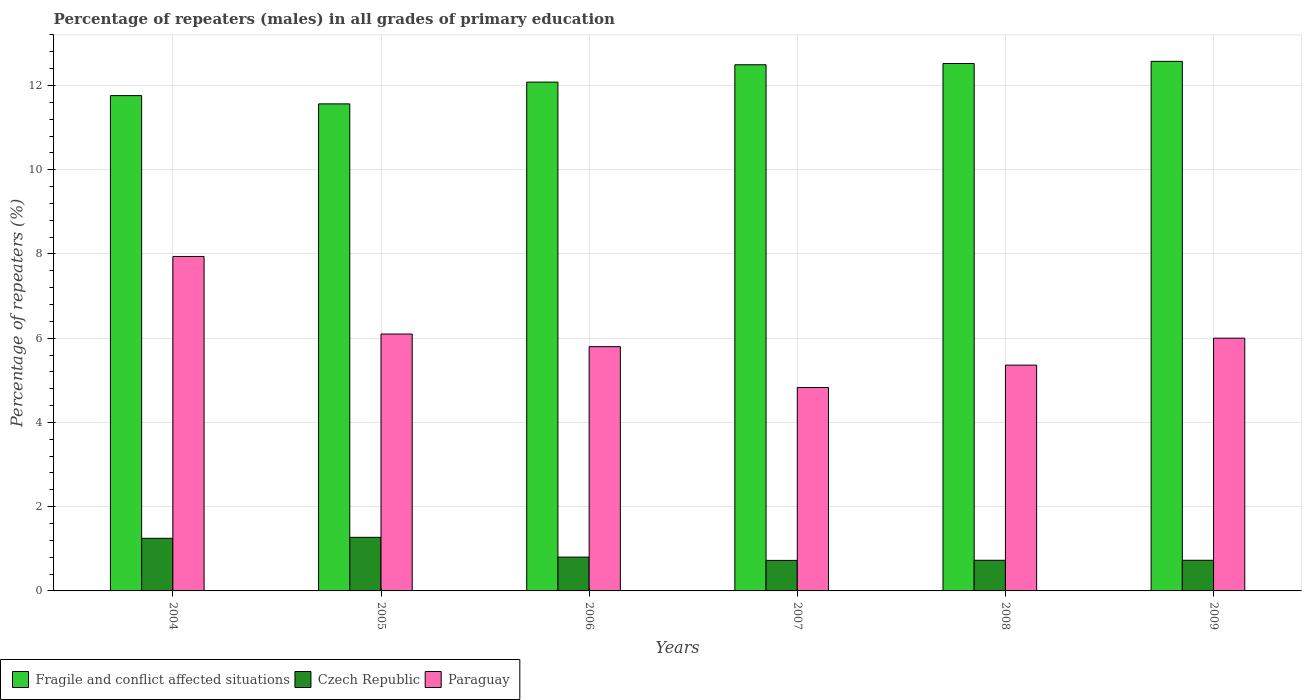Are the number of bars per tick equal to the number of legend labels?
Ensure brevity in your answer.  Yes. Are the number of bars on each tick of the X-axis equal?
Offer a terse response. Yes. What is the label of the 3rd group of bars from the left?
Your answer should be very brief. 2006. What is the percentage of repeaters (males) in Paraguay in 2005?
Ensure brevity in your answer.  6.1. Across all years, what is the maximum percentage of repeaters (males) in Paraguay?
Give a very brief answer. 7.94. Across all years, what is the minimum percentage of repeaters (males) in Paraguay?
Offer a terse response. 4.83. What is the total percentage of repeaters (males) in Paraguay in the graph?
Your answer should be very brief. 36.03. What is the difference between the percentage of repeaters (males) in Czech Republic in 2006 and that in 2009?
Your response must be concise. 0.07. What is the difference between the percentage of repeaters (males) in Fragile and conflict affected situations in 2008 and the percentage of repeaters (males) in Czech Republic in 2009?
Offer a very short reply. 11.8. What is the average percentage of repeaters (males) in Paraguay per year?
Offer a very short reply. 6.01. In the year 2004, what is the difference between the percentage of repeaters (males) in Fragile and conflict affected situations and percentage of repeaters (males) in Paraguay?
Provide a short and direct response. 3.82. In how many years, is the percentage of repeaters (males) in Czech Republic greater than 3.6 %?
Your response must be concise. 0. What is the ratio of the percentage of repeaters (males) in Fragile and conflict affected situations in 2005 to that in 2009?
Give a very brief answer. 0.92. What is the difference between the highest and the second highest percentage of repeaters (males) in Czech Republic?
Offer a very short reply. 0.02. What is the difference between the highest and the lowest percentage of repeaters (males) in Czech Republic?
Offer a very short reply. 0.55. Is the sum of the percentage of repeaters (males) in Czech Republic in 2005 and 2007 greater than the maximum percentage of repeaters (males) in Fragile and conflict affected situations across all years?
Make the answer very short. No. What does the 1st bar from the left in 2004 represents?
Your answer should be compact. Fragile and conflict affected situations. What does the 2nd bar from the right in 2005 represents?
Provide a short and direct response. Czech Republic. Is it the case that in every year, the sum of the percentage of repeaters (males) in Fragile and conflict affected situations and percentage of repeaters (males) in Paraguay is greater than the percentage of repeaters (males) in Czech Republic?
Your answer should be compact. Yes. How many bars are there?
Your response must be concise. 18. Are all the bars in the graph horizontal?
Your answer should be compact. No. How many years are there in the graph?
Your response must be concise. 6. What is the difference between two consecutive major ticks on the Y-axis?
Your answer should be very brief. 2. Are the values on the major ticks of Y-axis written in scientific E-notation?
Your answer should be very brief. No. Where does the legend appear in the graph?
Your answer should be very brief. Bottom left. What is the title of the graph?
Make the answer very short. Percentage of repeaters (males) in all grades of primary education. What is the label or title of the X-axis?
Provide a succinct answer. Years. What is the label or title of the Y-axis?
Give a very brief answer. Percentage of repeaters (%). What is the Percentage of repeaters (%) in Fragile and conflict affected situations in 2004?
Provide a short and direct response. 11.76. What is the Percentage of repeaters (%) in Czech Republic in 2004?
Provide a short and direct response. 1.25. What is the Percentage of repeaters (%) of Paraguay in 2004?
Your answer should be very brief. 7.94. What is the Percentage of repeaters (%) of Fragile and conflict affected situations in 2005?
Ensure brevity in your answer.  11.56. What is the Percentage of repeaters (%) of Czech Republic in 2005?
Offer a very short reply. 1.27. What is the Percentage of repeaters (%) of Paraguay in 2005?
Provide a short and direct response. 6.1. What is the Percentage of repeaters (%) of Fragile and conflict affected situations in 2006?
Offer a terse response. 12.08. What is the Percentage of repeaters (%) of Czech Republic in 2006?
Offer a terse response. 0.8. What is the Percentage of repeaters (%) in Paraguay in 2006?
Your response must be concise. 5.8. What is the Percentage of repeaters (%) in Fragile and conflict affected situations in 2007?
Offer a very short reply. 12.49. What is the Percentage of repeaters (%) of Czech Republic in 2007?
Keep it short and to the point. 0.72. What is the Percentage of repeaters (%) of Paraguay in 2007?
Offer a terse response. 4.83. What is the Percentage of repeaters (%) of Fragile and conflict affected situations in 2008?
Keep it short and to the point. 12.52. What is the Percentage of repeaters (%) in Czech Republic in 2008?
Give a very brief answer. 0.73. What is the Percentage of repeaters (%) in Paraguay in 2008?
Make the answer very short. 5.36. What is the Percentage of repeaters (%) of Fragile and conflict affected situations in 2009?
Make the answer very short. 12.57. What is the Percentage of repeaters (%) of Czech Republic in 2009?
Your answer should be compact. 0.73. What is the Percentage of repeaters (%) of Paraguay in 2009?
Your answer should be compact. 6. Across all years, what is the maximum Percentage of repeaters (%) in Fragile and conflict affected situations?
Ensure brevity in your answer.  12.57. Across all years, what is the maximum Percentage of repeaters (%) in Czech Republic?
Offer a terse response. 1.27. Across all years, what is the maximum Percentage of repeaters (%) in Paraguay?
Your answer should be compact. 7.94. Across all years, what is the minimum Percentage of repeaters (%) in Fragile and conflict affected situations?
Provide a short and direct response. 11.56. Across all years, what is the minimum Percentage of repeaters (%) in Czech Republic?
Give a very brief answer. 0.72. Across all years, what is the minimum Percentage of repeaters (%) of Paraguay?
Provide a short and direct response. 4.83. What is the total Percentage of repeaters (%) in Fragile and conflict affected situations in the graph?
Ensure brevity in your answer.  72.99. What is the total Percentage of repeaters (%) of Czech Republic in the graph?
Offer a very short reply. 5.5. What is the total Percentage of repeaters (%) of Paraguay in the graph?
Your answer should be compact. 36.03. What is the difference between the Percentage of repeaters (%) in Fragile and conflict affected situations in 2004 and that in 2005?
Offer a very short reply. 0.2. What is the difference between the Percentage of repeaters (%) in Czech Republic in 2004 and that in 2005?
Your response must be concise. -0.02. What is the difference between the Percentage of repeaters (%) of Paraguay in 2004 and that in 2005?
Ensure brevity in your answer.  1.84. What is the difference between the Percentage of repeaters (%) of Fragile and conflict affected situations in 2004 and that in 2006?
Your answer should be very brief. -0.32. What is the difference between the Percentage of repeaters (%) in Czech Republic in 2004 and that in 2006?
Provide a succinct answer. 0.45. What is the difference between the Percentage of repeaters (%) of Paraguay in 2004 and that in 2006?
Give a very brief answer. 2.14. What is the difference between the Percentage of repeaters (%) of Fragile and conflict affected situations in 2004 and that in 2007?
Your answer should be compact. -0.73. What is the difference between the Percentage of repeaters (%) in Czech Republic in 2004 and that in 2007?
Offer a very short reply. 0.52. What is the difference between the Percentage of repeaters (%) in Paraguay in 2004 and that in 2007?
Provide a short and direct response. 3.11. What is the difference between the Percentage of repeaters (%) of Fragile and conflict affected situations in 2004 and that in 2008?
Your answer should be compact. -0.76. What is the difference between the Percentage of repeaters (%) in Czech Republic in 2004 and that in 2008?
Provide a succinct answer. 0.52. What is the difference between the Percentage of repeaters (%) of Paraguay in 2004 and that in 2008?
Ensure brevity in your answer.  2.58. What is the difference between the Percentage of repeaters (%) of Fragile and conflict affected situations in 2004 and that in 2009?
Your response must be concise. -0.81. What is the difference between the Percentage of repeaters (%) in Czech Republic in 2004 and that in 2009?
Ensure brevity in your answer.  0.52. What is the difference between the Percentage of repeaters (%) of Paraguay in 2004 and that in 2009?
Ensure brevity in your answer.  1.94. What is the difference between the Percentage of repeaters (%) of Fragile and conflict affected situations in 2005 and that in 2006?
Your answer should be compact. -0.52. What is the difference between the Percentage of repeaters (%) of Czech Republic in 2005 and that in 2006?
Offer a terse response. 0.47. What is the difference between the Percentage of repeaters (%) of Paraguay in 2005 and that in 2006?
Offer a very short reply. 0.3. What is the difference between the Percentage of repeaters (%) of Fragile and conflict affected situations in 2005 and that in 2007?
Your answer should be compact. -0.93. What is the difference between the Percentage of repeaters (%) of Czech Republic in 2005 and that in 2007?
Keep it short and to the point. 0.55. What is the difference between the Percentage of repeaters (%) in Paraguay in 2005 and that in 2007?
Your answer should be very brief. 1.27. What is the difference between the Percentage of repeaters (%) of Fragile and conflict affected situations in 2005 and that in 2008?
Your answer should be very brief. -0.96. What is the difference between the Percentage of repeaters (%) of Czech Republic in 2005 and that in 2008?
Your answer should be very brief. 0.54. What is the difference between the Percentage of repeaters (%) in Paraguay in 2005 and that in 2008?
Keep it short and to the point. 0.74. What is the difference between the Percentage of repeaters (%) in Fragile and conflict affected situations in 2005 and that in 2009?
Your answer should be compact. -1.01. What is the difference between the Percentage of repeaters (%) of Czech Republic in 2005 and that in 2009?
Offer a very short reply. 0.54. What is the difference between the Percentage of repeaters (%) of Paraguay in 2005 and that in 2009?
Give a very brief answer. 0.1. What is the difference between the Percentage of repeaters (%) of Fragile and conflict affected situations in 2006 and that in 2007?
Keep it short and to the point. -0.41. What is the difference between the Percentage of repeaters (%) of Czech Republic in 2006 and that in 2007?
Ensure brevity in your answer.  0.08. What is the difference between the Percentage of repeaters (%) of Paraguay in 2006 and that in 2007?
Your answer should be compact. 0.97. What is the difference between the Percentage of repeaters (%) of Fragile and conflict affected situations in 2006 and that in 2008?
Your response must be concise. -0.44. What is the difference between the Percentage of repeaters (%) in Czech Republic in 2006 and that in 2008?
Keep it short and to the point. 0.08. What is the difference between the Percentage of repeaters (%) of Paraguay in 2006 and that in 2008?
Provide a succinct answer. 0.44. What is the difference between the Percentage of repeaters (%) of Fragile and conflict affected situations in 2006 and that in 2009?
Ensure brevity in your answer.  -0.49. What is the difference between the Percentage of repeaters (%) in Czech Republic in 2006 and that in 2009?
Keep it short and to the point. 0.07. What is the difference between the Percentage of repeaters (%) of Paraguay in 2006 and that in 2009?
Keep it short and to the point. -0.2. What is the difference between the Percentage of repeaters (%) of Fragile and conflict affected situations in 2007 and that in 2008?
Provide a short and direct response. -0.03. What is the difference between the Percentage of repeaters (%) of Czech Republic in 2007 and that in 2008?
Make the answer very short. -0. What is the difference between the Percentage of repeaters (%) in Paraguay in 2007 and that in 2008?
Ensure brevity in your answer.  -0.53. What is the difference between the Percentage of repeaters (%) in Fragile and conflict affected situations in 2007 and that in 2009?
Keep it short and to the point. -0.08. What is the difference between the Percentage of repeaters (%) in Czech Republic in 2007 and that in 2009?
Make the answer very short. -0. What is the difference between the Percentage of repeaters (%) in Paraguay in 2007 and that in 2009?
Keep it short and to the point. -1.17. What is the difference between the Percentage of repeaters (%) of Fragile and conflict affected situations in 2008 and that in 2009?
Your answer should be very brief. -0.05. What is the difference between the Percentage of repeaters (%) in Czech Republic in 2008 and that in 2009?
Your answer should be very brief. -0. What is the difference between the Percentage of repeaters (%) in Paraguay in 2008 and that in 2009?
Provide a short and direct response. -0.64. What is the difference between the Percentage of repeaters (%) of Fragile and conflict affected situations in 2004 and the Percentage of repeaters (%) of Czech Republic in 2005?
Your response must be concise. 10.49. What is the difference between the Percentage of repeaters (%) of Fragile and conflict affected situations in 2004 and the Percentage of repeaters (%) of Paraguay in 2005?
Make the answer very short. 5.66. What is the difference between the Percentage of repeaters (%) of Czech Republic in 2004 and the Percentage of repeaters (%) of Paraguay in 2005?
Your answer should be very brief. -4.85. What is the difference between the Percentage of repeaters (%) in Fragile and conflict affected situations in 2004 and the Percentage of repeaters (%) in Czech Republic in 2006?
Offer a terse response. 10.96. What is the difference between the Percentage of repeaters (%) in Fragile and conflict affected situations in 2004 and the Percentage of repeaters (%) in Paraguay in 2006?
Provide a short and direct response. 5.96. What is the difference between the Percentage of repeaters (%) in Czech Republic in 2004 and the Percentage of repeaters (%) in Paraguay in 2006?
Provide a short and direct response. -4.55. What is the difference between the Percentage of repeaters (%) of Fragile and conflict affected situations in 2004 and the Percentage of repeaters (%) of Czech Republic in 2007?
Offer a very short reply. 11.04. What is the difference between the Percentage of repeaters (%) in Fragile and conflict affected situations in 2004 and the Percentage of repeaters (%) in Paraguay in 2007?
Keep it short and to the point. 6.93. What is the difference between the Percentage of repeaters (%) of Czech Republic in 2004 and the Percentage of repeaters (%) of Paraguay in 2007?
Offer a very short reply. -3.58. What is the difference between the Percentage of repeaters (%) in Fragile and conflict affected situations in 2004 and the Percentage of repeaters (%) in Czech Republic in 2008?
Your answer should be compact. 11.03. What is the difference between the Percentage of repeaters (%) in Fragile and conflict affected situations in 2004 and the Percentage of repeaters (%) in Paraguay in 2008?
Your answer should be very brief. 6.4. What is the difference between the Percentage of repeaters (%) in Czech Republic in 2004 and the Percentage of repeaters (%) in Paraguay in 2008?
Ensure brevity in your answer.  -4.11. What is the difference between the Percentage of repeaters (%) in Fragile and conflict affected situations in 2004 and the Percentage of repeaters (%) in Czech Republic in 2009?
Your response must be concise. 11.03. What is the difference between the Percentage of repeaters (%) in Fragile and conflict affected situations in 2004 and the Percentage of repeaters (%) in Paraguay in 2009?
Your answer should be compact. 5.76. What is the difference between the Percentage of repeaters (%) in Czech Republic in 2004 and the Percentage of repeaters (%) in Paraguay in 2009?
Keep it short and to the point. -4.75. What is the difference between the Percentage of repeaters (%) of Fragile and conflict affected situations in 2005 and the Percentage of repeaters (%) of Czech Republic in 2006?
Ensure brevity in your answer.  10.76. What is the difference between the Percentage of repeaters (%) of Fragile and conflict affected situations in 2005 and the Percentage of repeaters (%) of Paraguay in 2006?
Give a very brief answer. 5.76. What is the difference between the Percentage of repeaters (%) of Czech Republic in 2005 and the Percentage of repeaters (%) of Paraguay in 2006?
Keep it short and to the point. -4.53. What is the difference between the Percentage of repeaters (%) in Fragile and conflict affected situations in 2005 and the Percentage of repeaters (%) in Czech Republic in 2007?
Provide a succinct answer. 10.84. What is the difference between the Percentage of repeaters (%) of Fragile and conflict affected situations in 2005 and the Percentage of repeaters (%) of Paraguay in 2007?
Your answer should be compact. 6.73. What is the difference between the Percentage of repeaters (%) in Czech Republic in 2005 and the Percentage of repeaters (%) in Paraguay in 2007?
Your response must be concise. -3.56. What is the difference between the Percentage of repeaters (%) in Fragile and conflict affected situations in 2005 and the Percentage of repeaters (%) in Czech Republic in 2008?
Make the answer very short. 10.84. What is the difference between the Percentage of repeaters (%) of Fragile and conflict affected situations in 2005 and the Percentage of repeaters (%) of Paraguay in 2008?
Ensure brevity in your answer.  6.2. What is the difference between the Percentage of repeaters (%) of Czech Republic in 2005 and the Percentage of repeaters (%) of Paraguay in 2008?
Make the answer very short. -4.09. What is the difference between the Percentage of repeaters (%) in Fragile and conflict affected situations in 2005 and the Percentage of repeaters (%) in Czech Republic in 2009?
Keep it short and to the point. 10.84. What is the difference between the Percentage of repeaters (%) of Fragile and conflict affected situations in 2005 and the Percentage of repeaters (%) of Paraguay in 2009?
Make the answer very short. 5.56. What is the difference between the Percentage of repeaters (%) in Czech Republic in 2005 and the Percentage of repeaters (%) in Paraguay in 2009?
Keep it short and to the point. -4.73. What is the difference between the Percentage of repeaters (%) of Fragile and conflict affected situations in 2006 and the Percentage of repeaters (%) of Czech Republic in 2007?
Provide a succinct answer. 11.36. What is the difference between the Percentage of repeaters (%) of Fragile and conflict affected situations in 2006 and the Percentage of repeaters (%) of Paraguay in 2007?
Your answer should be very brief. 7.25. What is the difference between the Percentage of repeaters (%) of Czech Republic in 2006 and the Percentage of repeaters (%) of Paraguay in 2007?
Keep it short and to the point. -4.03. What is the difference between the Percentage of repeaters (%) in Fragile and conflict affected situations in 2006 and the Percentage of repeaters (%) in Czech Republic in 2008?
Provide a succinct answer. 11.35. What is the difference between the Percentage of repeaters (%) of Fragile and conflict affected situations in 2006 and the Percentage of repeaters (%) of Paraguay in 2008?
Offer a terse response. 6.72. What is the difference between the Percentage of repeaters (%) of Czech Republic in 2006 and the Percentage of repeaters (%) of Paraguay in 2008?
Offer a very short reply. -4.56. What is the difference between the Percentage of repeaters (%) in Fragile and conflict affected situations in 2006 and the Percentage of repeaters (%) in Czech Republic in 2009?
Make the answer very short. 11.35. What is the difference between the Percentage of repeaters (%) in Fragile and conflict affected situations in 2006 and the Percentage of repeaters (%) in Paraguay in 2009?
Offer a very short reply. 6.08. What is the difference between the Percentage of repeaters (%) in Czech Republic in 2006 and the Percentage of repeaters (%) in Paraguay in 2009?
Your response must be concise. -5.2. What is the difference between the Percentage of repeaters (%) of Fragile and conflict affected situations in 2007 and the Percentage of repeaters (%) of Czech Republic in 2008?
Your response must be concise. 11.77. What is the difference between the Percentage of repeaters (%) in Fragile and conflict affected situations in 2007 and the Percentage of repeaters (%) in Paraguay in 2008?
Your answer should be compact. 7.13. What is the difference between the Percentage of repeaters (%) of Czech Republic in 2007 and the Percentage of repeaters (%) of Paraguay in 2008?
Make the answer very short. -4.64. What is the difference between the Percentage of repeaters (%) of Fragile and conflict affected situations in 2007 and the Percentage of repeaters (%) of Czech Republic in 2009?
Your answer should be very brief. 11.77. What is the difference between the Percentage of repeaters (%) in Fragile and conflict affected situations in 2007 and the Percentage of repeaters (%) in Paraguay in 2009?
Keep it short and to the point. 6.49. What is the difference between the Percentage of repeaters (%) in Czech Republic in 2007 and the Percentage of repeaters (%) in Paraguay in 2009?
Keep it short and to the point. -5.28. What is the difference between the Percentage of repeaters (%) of Fragile and conflict affected situations in 2008 and the Percentage of repeaters (%) of Czech Republic in 2009?
Offer a very short reply. 11.8. What is the difference between the Percentage of repeaters (%) of Fragile and conflict affected situations in 2008 and the Percentage of repeaters (%) of Paraguay in 2009?
Your answer should be compact. 6.52. What is the difference between the Percentage of repeaters (%) in Czech Republic in 2008 and the Percentage of repeaters (%) in Paraguay in 2009?
Provide a succinct answer. -5.27. What is the average Percentage of repeaters (%) in Fragile and conflict affected situations per year?
Your answer should be compact. 12.17. What is the average Percentage of repeaters (%) of Czech Republic per year?
Your answer should be very brief. 0.92. What is the average Percentage of repeaters (%) of Paraguay per year?
Ensure brevity in your answer.  6.01. In the year 2004, what is the difference between the Percentage of repeaters (%) in Fragile and conflict affected situations and Percentage of repeaters (%) in Czech Republic?
Ensure brevity in your answer.  10.51. In the year 2004, what is the difference between the Percentage of repeaters (%) in Fragile and conflict affected situations and Percentage of repeaters (%) in Paraguay?
Your answer should be very brief. 3.82. In the year 2004, what is the difference between the Percentage of repeaters (%) in Czech Republic and Percentage of repeaters (%) in Paraguay?
Your answer should be compact. -6.69. In the year 2005, what is the difference between the Percentage of repeaters (%) of Fragile and conflict affected situations and Percentage of repeaters (%) of Czech Republic?
Offer a very short reply. 10.29. In the year 2005, what is the difference between the Percentage of repeaters (%) in Fragile and conflict affected situations and Percentage of repeaters (%) in Paraguay?
Provide a short and direct response. 5.46. In the year 2005, what is the difference between the Percentage of repeaters (%) of Czech Republic and Percentage of repeaters (%) of Paraguay?
Keep it short and to the point. -4.83. In the year 2006, what is the difference between the Percentage of repeaters (%) of Fragile and conflict affected situations and Percentage of repeaters (%) of Czech Republic?
Your response must be concise. 11.28. In the year 2006, what is the difference between the Percentage of repeaters (%) of Fragile and conflict affected situations and Percentage of repeaters (%) of Paraguay?
Give a very brief answer. 6.28. In the year 2006, what is the difference between the Percentage of repeaters (%) in Czech Republic and Percentage of repeaters (%) in Paraguay?
Provide a short and direct response. -5. In the year 2007, what is the difference between the Percentage of repeaters (%) of Fragile and conflict affected situations and Percentage of repeaters (%) of Czech Republic?
Make the answer very short. 11.77. In the year 2007, what is the difference between the Percentage of repeaters (%) of Fragile and conflict affected situations and Percentage of repeaters (%) of Paraguay?
Give a very brief answer. 7.66. In the year 2007, what is the difference between the Percentage of repeaters (%) of Czech Republic and Percentage of repeaters (%) of Paraguay?
Provide a succinct answer. -4.11. In the year 2008, what is the difference between the Percentage of repeaters (%) of Fragile and conflict affected situations and Percentage of repeaters (%) of Czech Republic?
Ensure brevity in your answer.  11.8. In the year 2008, what is the difference between the Percentage of repeaters (%) of Fragile and conflict affected situations and Percentage of repeaters (%) of Paraguay?
Your answer should be very brief. 7.16. In the year 2008, what is the difference between the Percentage of repeaters (%) of Czech Republic and Percentage of repeaters (%) of Paraguay?
Provide a succinct answer. -4.63. In the year 2009, what is the difference between the Percentage of repeaters (%) of Fragile and conflict affected situations and Percentage of repeaters (%) of Czech Republic?
Your answer should be compact. 11.85. In the year 2009, what is the difference between the Percentage of repeaters (%) in Fragile and conflict affected situations and Percentage of repeaters (%) in Paraguay?
Make the answer very short. 6.57. In the year 2009, what is the difference between the Percentage of repeaters (%) of Czech Republic and Percentage of repeaters (%) of Paraguay?
Provide a short and direct response. -5.27. What is the ratio of the Percentage of repeaters (%) of Fragile and conflict affected situations in 2004 to that in 2005?
Keep it short and to the point. 1.02. What is the ratio of the Percentage of repeaters (%) of Czech Republic in 2004 to that in 2005?
Your answer should be compact. 0.98. What is the ratio of the Percentage of repeaters (%) in Paraguay in 2004 to that in 2005?
Your answer should be very brief. 1.3. What is the ratio of the Percentage of repeaters (%) in Fragile and conflict affected situations in 2004 to that in 2006?
Make the answer very short. 0.97. What is the ratio of the Percentage of repeaters (%) of Czech Republic in 2004 to that in 2006?
Give a very brief answer. 1.56. What is the ratio of the Percentage of repeaters (%) in Paraguay in 2004 to that in 2006?
Keep it short and to the point. 1.37. What is the ratio of the Percentage of repeaters (%) in Fragile and conflict affected situations in 2004 to that in 2007?
Your answer should be very brief. 0.94. What is the ratio of the Percentage of repeaters (%) of Czech Republic in 2004 to that in 2007?
Your response must be concise. 1.72. What is the ratio of the Percentage of repeaters (%) of Paraguay in 2004 to that in 2007?
Provide a short and direct response. 1.64. What is the ratio of the Percentage of repeaters (%) of Fragile and conflict affected situations in 2004 to that in 2008?
Provide a short and direct response. 0.94. What is the ratio of the Percentage of repeaters (%) of Czech Republic in 2004 to that in 2008?
Provide a short and direct response. 1.72. What is the ratio of the Percentage of repeaters (%) in Paraguay in 2004 to that in 2008?
Your answer should be very brief. 1.48. What is the ratio of the Percentage of repeaters (%) of Fragile and conflict affected situations in 2004 to that in 2009?
Your answer should be compact. 0.94. What is the ratio of the Percentage of repeaters (%) of Czech Republic in 2004 to that in 2009?
Offer a very short reply. 1.72. What is the ratio of the Percentage of repeaters (%) in Paraguay in 2004 to that in 2009?
Offer a very short reply. 1.32. What is the ratio of the Percentage of repeaters (%) in Fragile and conflict affected situations in 2005 to that in 2006?
Provide a short and direct response. 0.96. What is the ratio of the Percentage of repeaters (%) in Czech Republic in 2005 to that in 2006?
Offer a terse response. 1.58. What is the ratio of the Percentage of repeaters (%) of Paraguay in 2005 to that in 2006?
Your response must be concise. 1.05. What is the ratio of the Percentage of repeaters (%) of Fragile and conflict affected situations in 2005 to that in 2007?
Make the answer very short. 0.93. What is the ratio of the Percentage of repeaters (%) in Czech Republic in 2005 to that in 2007?
Offer a very short reply. 1.76. What is the ratio of the Percentage of repeaters (%) of Paraguay in 2005 to that in 2007?
Ensure brevity in your answer.  1.26. What is the ratio of the Percentage of repeaters (%) in Fragile and conflict affected situations in 2005 to that in 2008?
Your response must be concise. 0.92. What is the ratio of the Percentage of repeaters (%) of Czech Republic in 2005 to that in 2008?
Make the answer very short. 1.75. What is the ratio of the Percentage of repeaters (%) in Paraguay in 2005 to that in 2008?
Offer a terse response. 1.14. What is the ratio of the Percentage of repeaters (%) in Fragile and conflict affected situations in 2005 to that in 2009?
Give a very brief answer. 0.92. What is the ratio of the Percentage of repeaters (%) of Czech Republic in 2005 to that in 2009?
Offer a terse response. 1.75. What is the ratio of the Percentage of repeaters (%) of Paraguay in 2005 to that in 2009?
Your answer should be very brief. 1.02. What is the ratio of the Percentage of repeaters (%) of Fragile and conflict affected situations in 2006 to that in 2007?
Give a very brief answer. 0.97. What is the ratio of the Percentage of repeaters (%) of Czech Republic in 2006 to that in 2007?
Ensure brevity in your answer.  1.11. What is the ratio of the Percentage of repeaters (%) in Paraguay in 2006 to that in 2007?
Your response must be concise. 1.2. What is the ratio of the Percentage of repeaters (%) of Fragile and conflict affected situations in 2006 to that in 2008?
Your answer should be compact. 0.96. What is the ratio of the Percentage of repeaters (%) of Czech Republic in 2006 to that in 2008?
Provide a short and direct response. 1.1. What is the ratio of the Percentage of repeaters (%) in Paraguay in 2006 to that in 2008?
Give a very brief answer. 1.08. What is the ratio of the Percentage of repeaters (%) of Fragile and conflict affected situations in 2006 to that in 2009?
Your answer should be compact. 0.96. What is the ratio of the Percentage of repeaters (%) in Czech Republic in 2006 to that in 2009?
Ensure brevity in your answer.  1.1. What is the ratio of the Percentage of repeaters (%) in Paraguay in 2006 to that in 2009?
Your response must be concise. 0.97. What is the ratio of the Percentage of repeaters (%) in Czech Republic in 2007 to that in 2008?
Keep it short and to the point. 1. What is the ratio of the Percentage of repeaters (%) of Paraguay in 2007 to that in 2008?
Provide a succinct answer. 0.9. What is the ratio of the Percentage of repeaters (%) of Fragile and conflict affected situations in 2007 to that in 2009?
Your answer should be compact. 0.99. What is the ratio of the Percentage of repeaters (%) of Czech Republic in 2007 to that in 2009?
Keep it short and to the point. 1. What is the ratio of the Percentage of repeaters (%) in Paraguay in 2007 to that in 2009?
Your response must be concise. 0.8. What is the ratio of the Percentage of repeaters (%) of Czech Republic in 2008 to that in 2009?
Keep it short and to the point. 1. What is the ratio of the Percentage of repeaters (%) of Paraguay in 2008 to that in 2009?
Provide a succinct answer. 0.89. What is the difference between the highest and the second highest Percentage of repeaters (%) in Fragile and conflict affected situations?
Ensure brevity in your answer.  0.05. What is the difference between the highest and the second highest Percentage of repeaters (%) of Czech Republic?
Provide a succinct answer. 0.02. What is the difference between the highest and the second highest Percentage of repeaters (%) of Paraguay?
Make the answer very short. 1.84. What is the difference between the highest and the lowest Percentage of repeaters (%) in Fragile and conflict affected situations?
Your response must be concise. 1.01. What is the difference between the highest and the lowest Percentage of repeaters (%) of Czech Republic?
Offer a terse response. 0.55. What is the difference between the highest and the lowest Percentage of repeaters (%) of Paraguay?
Provide a succinct answer. 3.11. 